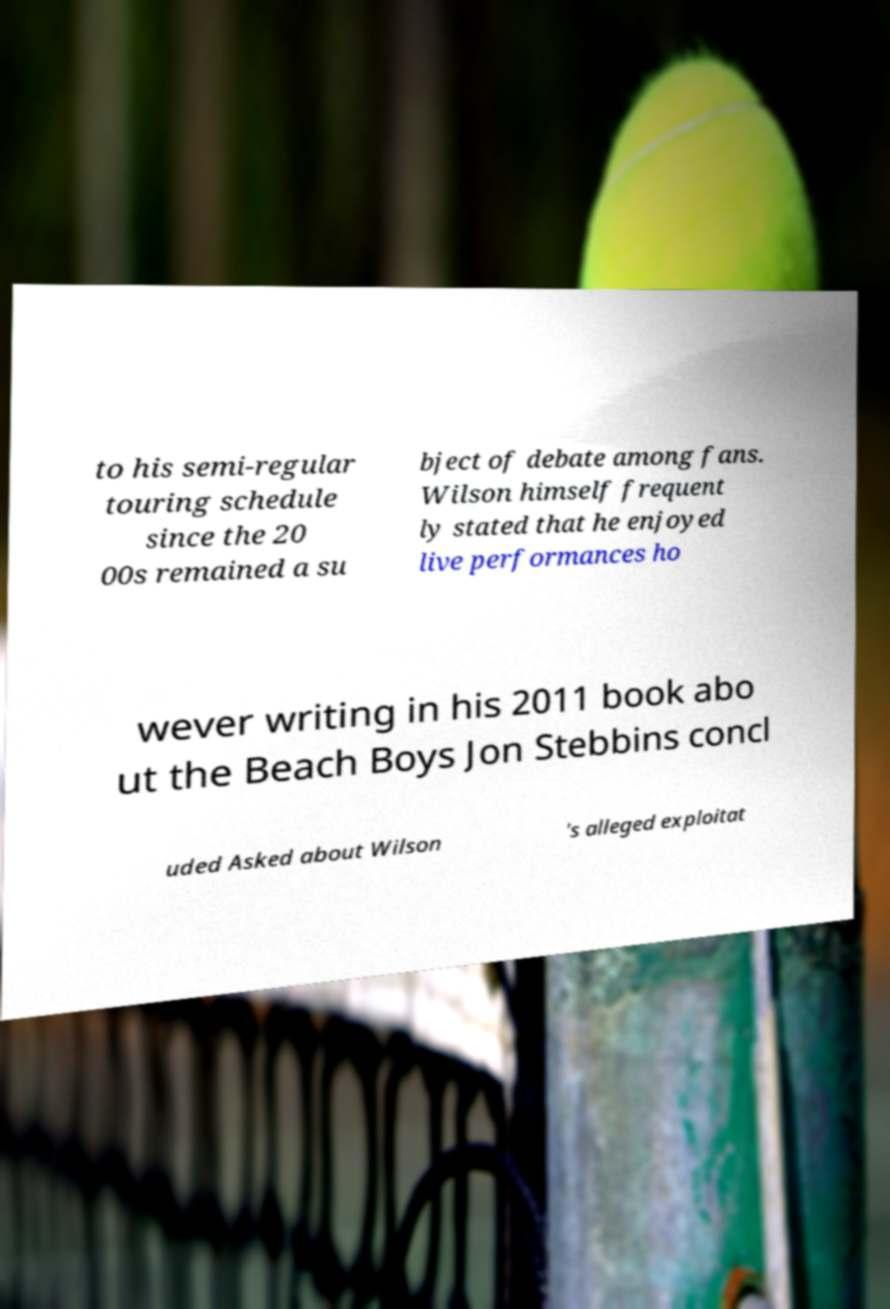Could you assist in decoding the text presented in this image and type it out clearly? to his semi-regular touring schedule since the 20 00s remained a su bject of debate among fans. Wilson himself frequent ly stated that he enjoyed live performances ho wever writing in his 2011 book abo ut the Beach Boys Jon Stebbins concl uded Asked about Wilson 's alleged exploitat 